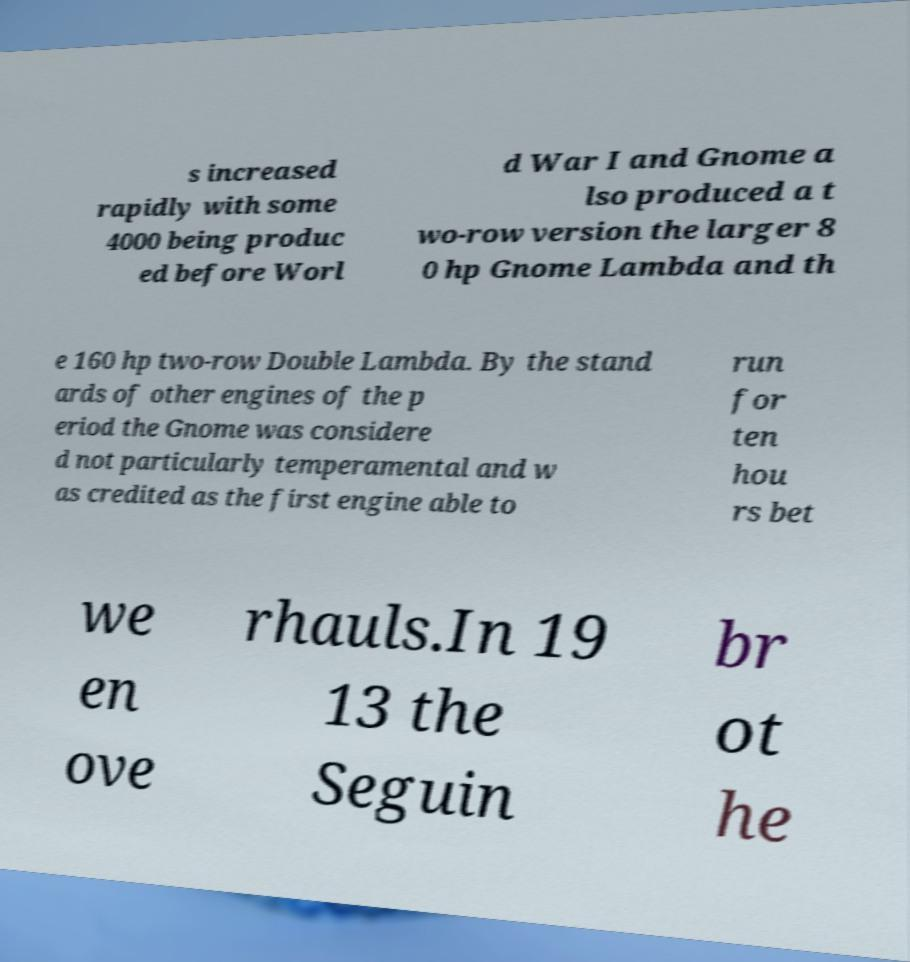I need the written content from this picture converted into text. Can you do that? s increased rapidly with some 4000 being produc ed before Worl d War I and Gnome a lso produced a t wo-row version the larger 8 0 hp Gnome Lambda and th e 160 hp two-row Double Lambda. By the stand ards of other engines of the p eriod the Gnome was considere d not particularly temperamental and w as credited as the first engine able to run for ten hou rs bet we en ove rhauls.In 19 13 the Seguin br ot he 